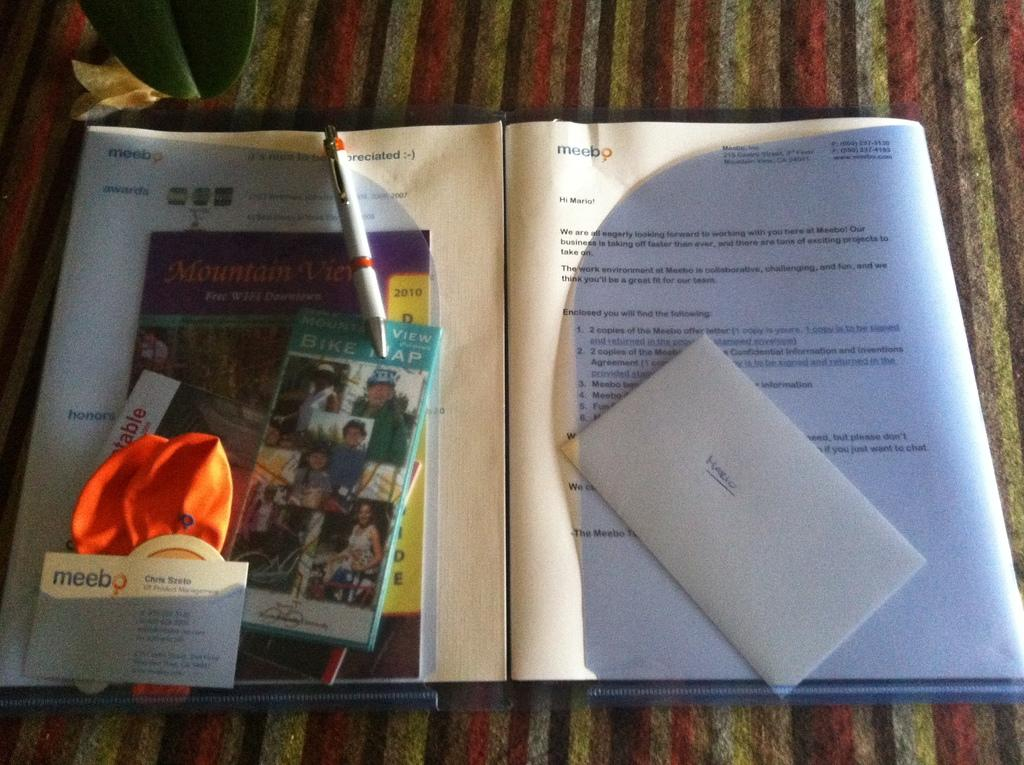<image>
Present a compact description of the photo's key features. A folder that is open on a table has pamphlets on it for Mountain View vacation destination and bike trails. 